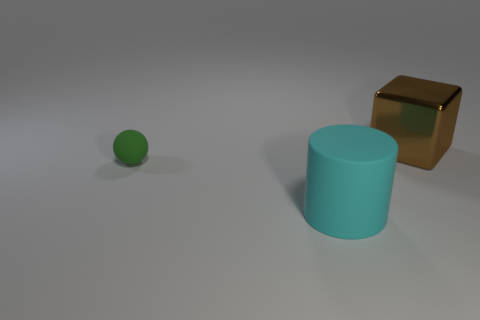The object that is on the left side of the big brown metallic object and to the right of the tiny sphere is made of what material?
Offer a very short reply. Rubber. Are there the same number of rubber balls behind the cyan matte thing and cyan rubber things?
Provide a short and direct response. Yes. What number of objects are big things that are behind the big cyan rubber thing or blue shiny objects?
Your answer should be compact. 1. There is a large object that is behind the large matte cylinder; is its color the same as the big matte cylinder?
Offer a terse response. No. There is a rubber thing behind the large cyan thing; what is its size?
Make the answer very short. Small. There is a large thing that is to the left of the thing behind the rubber ball; what shape is it?
Your response must be concise. Cylinder. There is a matte object that is to the right of the ball; does it have the same size as the small object?
Provide a short and direct response. No. How many big things are made of the same material as the tiny ball?
Provide a short and direct response. 1. What is the material of the big object that is to the right of the big thing that is left of the large object right of the big cyan object?
Your answer should be very brief. Metal. The object to the left of the big thing that is in front of the shiny thing is what color?
Keep it short and to the point. Green. 